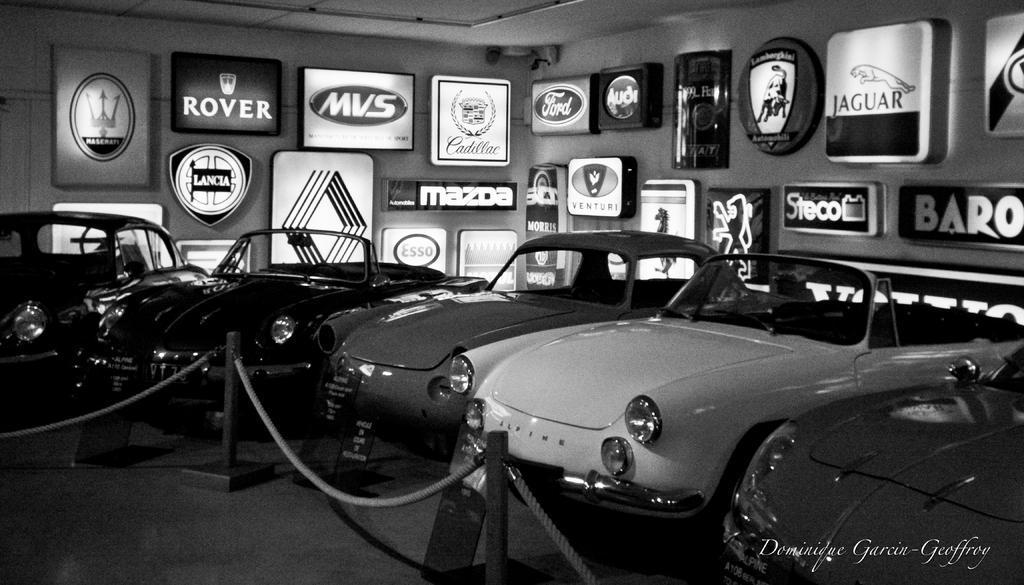Could you give a brief overview of what you see in this image? This is a black and white pic. We can see vehicles on the floor, rope and pole barrier and there are light boards on the wall and ceiling. 